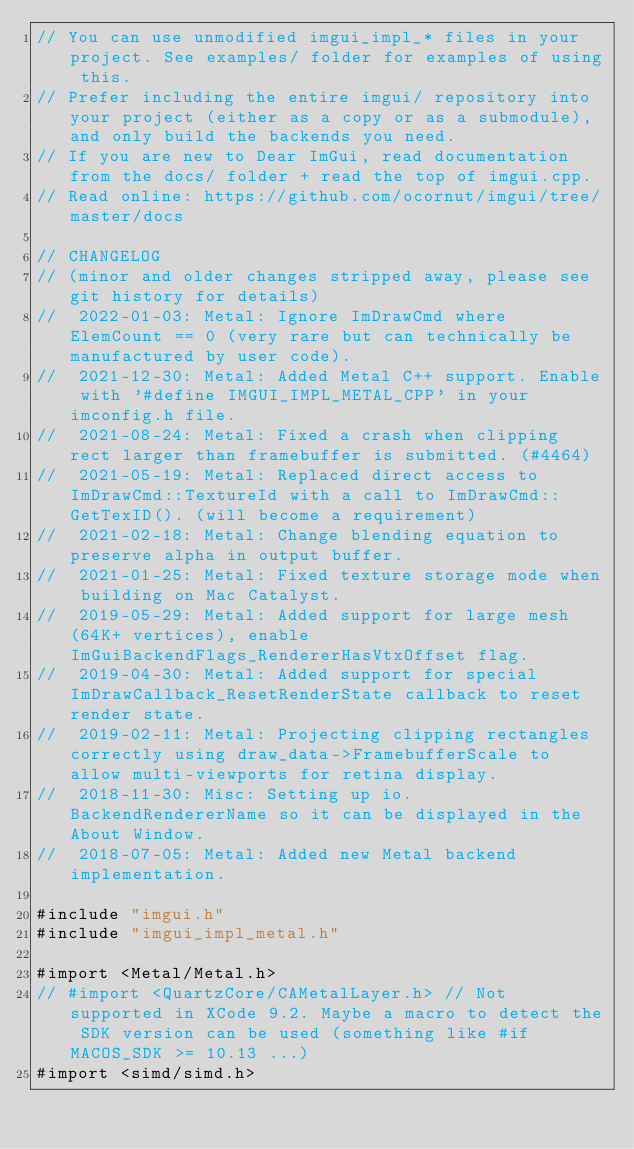<code> <loc_0><loc_0><loc_500><loc_500><_ObjectiveC_>// You can use unmodified imgui_impl_* files in your project. See examples/ folder for examples of using this.
// Prefer including the entire imgui/ repository into your project (either as a copy or as a submodule), and only build the backends you need.
// If you are new to Dear ImGui, read documentation from the docs/ folder + read the top of imgui.cpp.
// Read online: https://github.com/ocornut/imgui/tree/master/docs

// CHANGELOG
// (minor and older changes stripped away, please see git history for details)
//  2022-01-03: Metal: Ignore ImDrawCmd where ElemCount == 0 (very rare but can technically be manufactured by user code).
//  2021-12-30: Metal: Added Metal C++ support. Enable with '#define IMGUI_IMPL_METAL_CPP' in your imconfig.h file.
//  2021-08-24: Metal: Fixed a crash when clipping rect larger than framebuffer is submitted. (#4464)
//  2021-05-19: Metal: Replaced direct access to ImDrawCmd::TextureId with a call to ImDrawCmd::GetTexID(). (will become a requirement)
//  2021-02-18: Metal: Change blending equation to preserve alpha in output buffer.
//  2021-01-25: Metal: Fixed texture storage mode when building on Mac Catalyst.
//  2019-05-29: Metal: Added support for large mesh (64K+ vertices), enable ImGuiBackendFlags_RendererHasVtxOffset flag.
//  2019-04-30: Metal: Added support for special ImDrawCallback_ResetRenderState callback to reset render state.
//  2019-02-11: Metal: Projecting clipping rectangles correctly using draw_data->FramebufferScale to allow multi-viewports for retina display.
//  2018-11-30: Misc: Setting up io.BackendRendererName so it can be displayed in the About Window.
//  2018-07-05: Metal: Added new Metal backend implementation.

#include "imgui.h"
#include "imgui_impl_metal.h"

#import <Metal/Metal.h>
// #import <QuartzCore/CAMetalLayer.h> // Not supported in XCode 9.2. Maybe a macro to detect the SDK version can be used (something like #if MACOS_SDK >= 10.13 ...)
#import <simd/simd.h>
</code> 